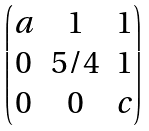Convert formula to latex. <formula><loc_0><loc_0><loc_500><loc_500>\begin{pmatrix} a & 1 & 1 \\ 0 & 5 / 4 & 1 \\ 0 & 0 & c \end{pmatrix}</formula> 